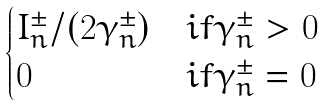<formula> <loc_0><loc_0><loc_500><loc_500>\begin{cases} I ^ { \pm } _ { n } / ( 2 \gamma ^ { \pm } _ { n } ) & i f \gamma ^ { \pm } _ { n } > 0 \\ 0 & i f \gamma ^ { \pm } _ { n } = 0 \end{cases}</formula> 